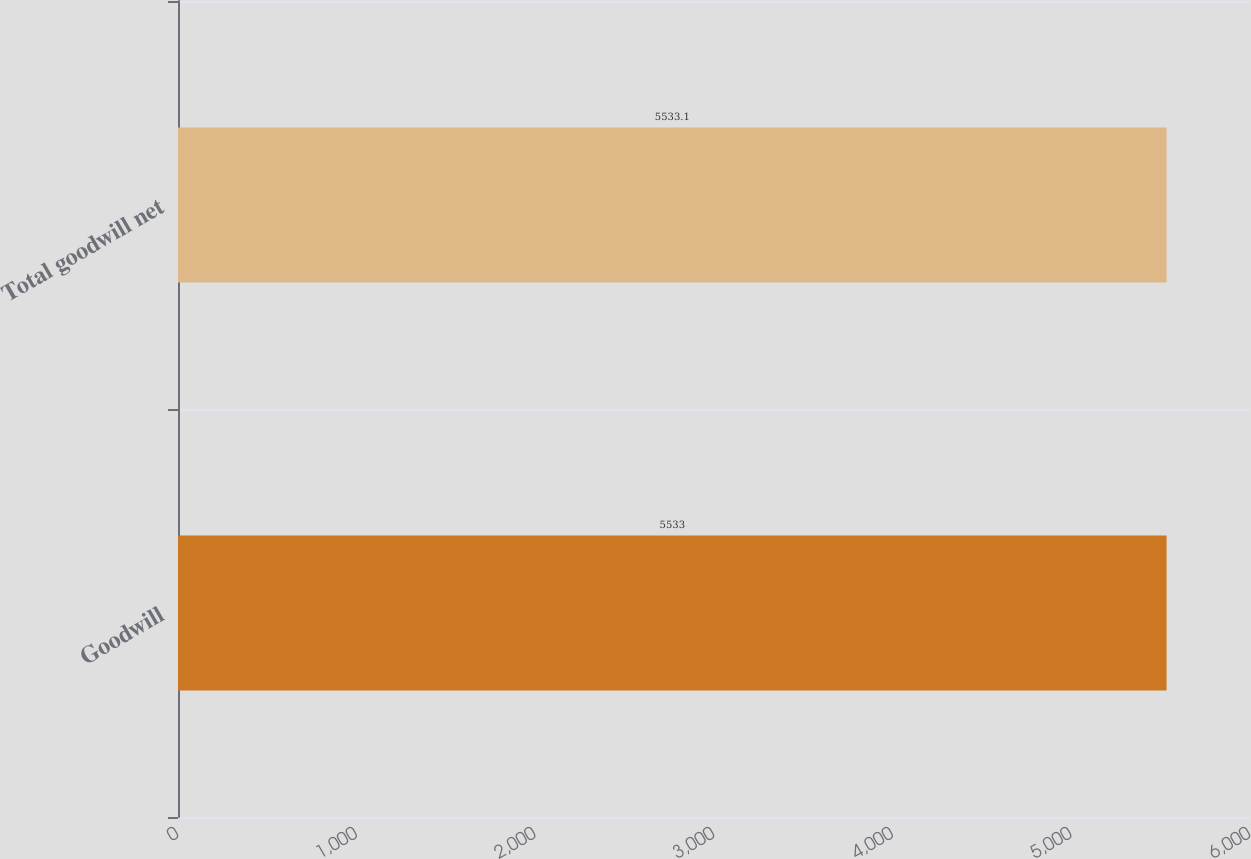Convert chart to OTSL. <chart><loc_0><loc_0><loc_500><loc_500><bar_chart><fcel>Goodwill<fcel>Total goodwill net<nl><fcel>5533<fcel>5533.1<nl></chart> 